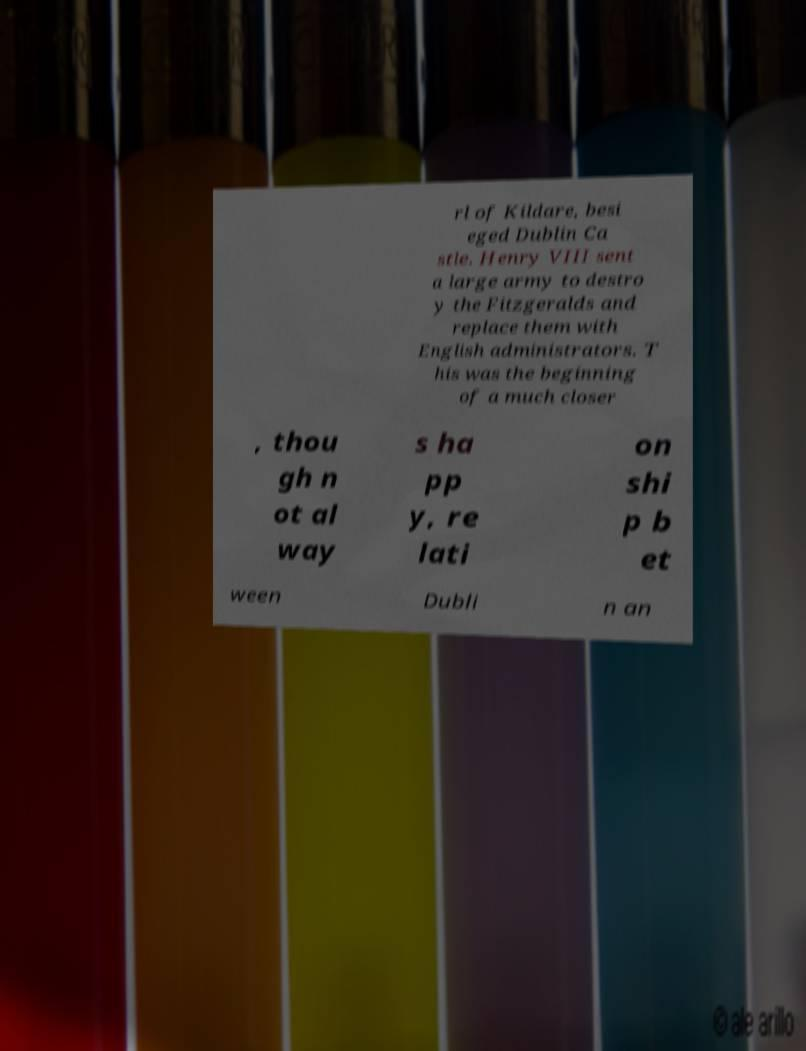Please read and relay the text visible in this image. What does it say? rl of Kildare, besi eged Dublin Ca stle. Henry VIII sent a large army to destro y the Fitzgeralds and replace them with English administrators. T his was the beginning of a much closer , thou gh n ot al way s ha pp y, re lati on shi p b et ween Dubli n an 